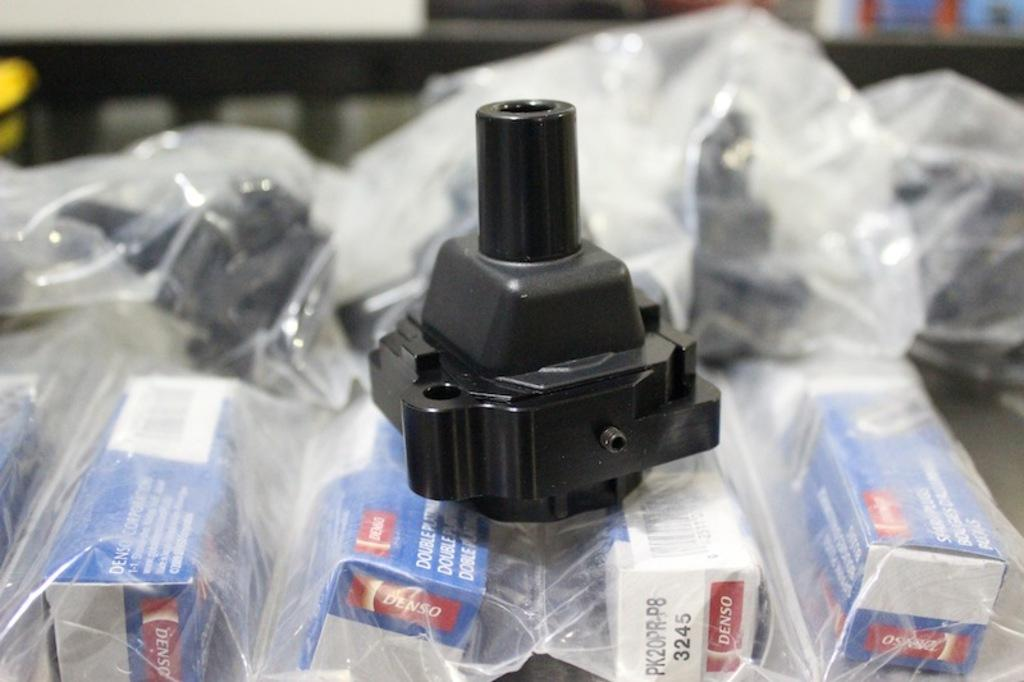What is the main subject in the center of the image? There is an object in the center of the image. What can be seen in the background of the image? There is a wall and other objects visible in the background of the image. What is located at the bottom of the image? There are boxes at the bottom of the image, and they contain packed objects. How does the sneeze affect the place in the image? There is no sneeze present in the image, so it cannot affect the place. 